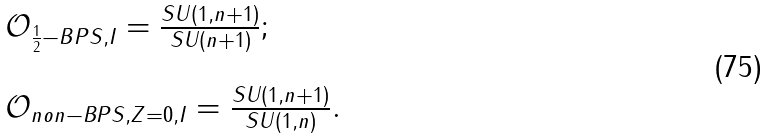<formula> <loc_0><loc_0><loc_500><loc_500>\begin{array} { l } \mathcal { O } _ { \frac { 1 } { 2 } - B P S , I } = \frac { S U ( 1 , n + 1 ) } { S U ( n + 1 ) } ; \\ \\ \mathcal { O } _ { n o n - B P S , Z = 0 , I } = \frac { S U ( 1 , n + 1 ) } { S U ( 1 , n ) } . \end{array}</formula> 